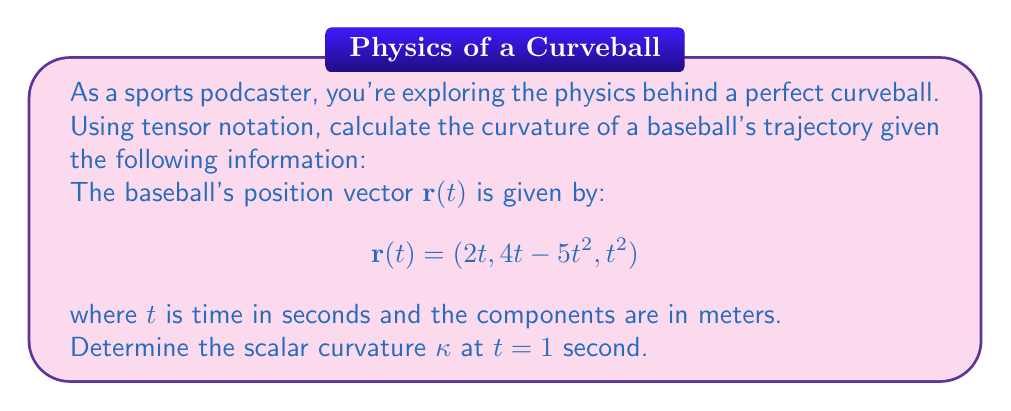Provide a solution to this math problem. To calculate the curvature of the baseball's trajectory using tensor notation, we'll follow these steps:

1) First, we need to calculate the velocity vector $\mathbf{v}(t)$ by differentiating $\mathbf{r}(t)$:
   $$\mathbf{v}(t) = \frac{d\mathbf{r}}{dt} = (2, 4 - 10t, 2t)$$

2) Next, we calculate the acceleration vector $\mathbf{a}(t)$ by differentiating $\mathbf{v}(t)$:
   $$\mathbf{a}(t) = \frac{d\mathbf{v}}{dt} = (0, -10, 2)$$

3) The curvature $\kappa$ is given by the formula:
   $$\kappa = \frac{\sqrt{|\mathbf{v} \times \mathbf{a}|^2}}{|\mathbf{v}|^3}$$

4) Let's calculate each component at $t = 1$:
   $\mathbf{v}(1) = (2, -6, 2)$
   $\mathbf{a}(1) = (0, -10, 2)$

5) Now, we calculate $\mathbf{v} \times \mathbf{a}$:
   $$\mathbf{v} \times \mathbf{a} = \begin{vmatrix} 
   \mathbf{i} & \mathbf{j} & \mathbf{k} \\
   2 & -6 & 2 \\
   0 & -10 & 2
   \end{vmatrix} = (8, 4, 20)$$

6) Calculate $|\mathbf{v} \times \mathbf{a}|^2$:
   $|\mathbf{v} \times \mathbf{a}|^2 = 8^2 + 4^2 + 20^2 = 480$

7) Calculate $|\mathbf{v}|^3$:
   $|\mathbf{v}| = \sqrt{2^2 + (-6)^2 + 2^2} = \sqrt{44}$
   $|\mathbf{v}|^3 = (\sqrt{44})^3 = 44\sqrt{44}$

8) Finally, we can calculate $\kappa$:
   $$\kappa = \frac{\sqrt{480}}{44\sqrt{44}} = \frac{\sqrt{480}}{44\sqrt{44}} = \frac{\sqrt{30}}{22\sqrt{11}}$$
Answer: $\kappa = \frac{\sqrt{30}}{22\sqrt{11}}$ m^(-1) 